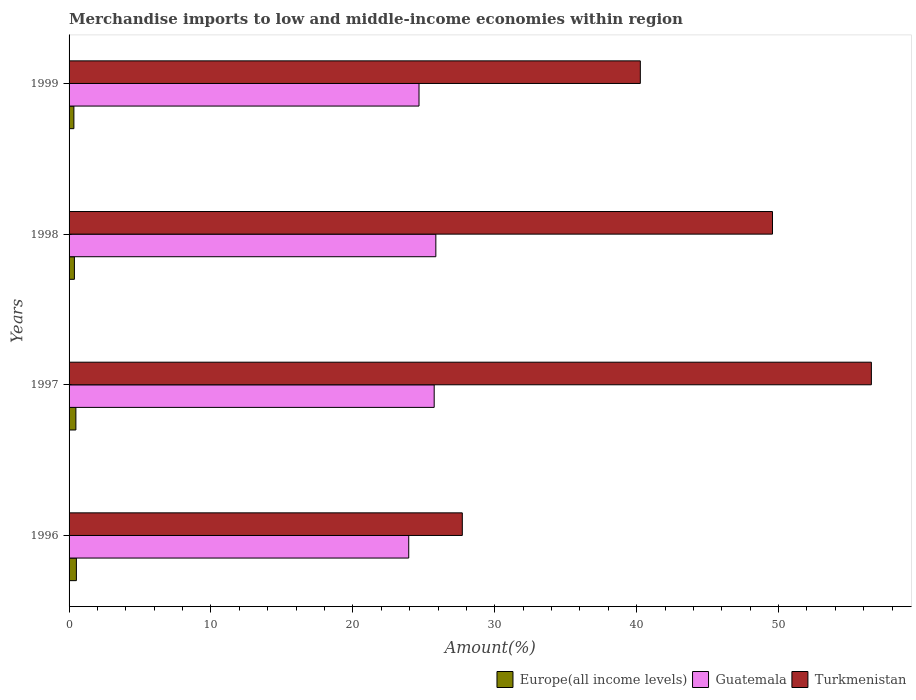Are the number of bars per tick equal to the number of legend labels?
Your answer should be compact. Yes. In how many cases, is the number of bars for a given year not equal to the number of legend labels?
Offer a terse response. 0. What is the percentage of amount earned from merchandise imports in Guatemala in 1999?
Offer a terse response. 24.66. Across all years, what is the maximum percentage of amount earned from merchandise imports in Guatemala?
Your response must be concise. 25.85. Across all years, what is the minimum percentage of amount earned from merchandise imports in Guatemala?
Make the answer very short. 23.94. In which year was the percentage of amount earned from merchandise imports in Turkmenistan minimum?
Provide a succinct answer. 1996. What is the total percentage of amount earned from merchandise imports in Guatemala in the graph?
Give a very brief answer. 100.17. What is the difference between the percentage of amount earned from merchandise imports in Europe(all income levels) in 1996 and that in 1999?
Give a very brief answer. 0.18. What is the difference between the percentage of amount earned from merchandise imports in Guatemala in 1998 and the percentage of amount earned from merchandise imports in Europe(all income levels) in 1999?
Your answer should be compact. 25.51. What is the average percentage of amount earned from merchandise imports in Europe(all income levels) per year?
Offer a terse response. 0.43. In the year 1996, what is the difference between the percentage of amount earned from merchandise imports in Europe(all income levels) and percentage of amount earned from merchandise imports in Turkmenistan?
Offer a very short reply. -27.2. In how many years, is the percentage of amount earned from merchandise imports in Turkmenistan greater than 36 %?
Provide a short and direct response. 3. What is the ratio of the percentage of amount earned from merchandise imports in Turkmenistan in 1996 to that in 1997?
Provide a succinct answer. 0.49. Is the difference between the percentage of amount earned from merchandise imports in Europe(all income levels) in 1996 and 1999 greater than the difference between the percentage of amount earned from merchandise imports in Turkmenistan in 1996 and 1999?
Offer a very short reply. Yes. What is the difference between the highest and the second highest percentage of amount earned from merchandise imports in Europe(all income levels)?
Ensure brevity in your answer.  0.04. What is the difference between the highest and the lowest percentage of amount earned from merchandise imports in Turkmenistan?
Provide a short and direct response. 28.83. What does the 2nd bar from the top in 1998 represents?
Provide a succinct answer. Guatemala. What does the 3rd bar from the bottom in 1998 represents?
Offer a very short reply. Turkmenistan. How many bars are there?
Your answer should be very brief. 12. What is the difference between two consecutive major ticks on the X-axis?
Keep it short and to the point. 10. What is the title of the graph?
Your response must be concise. Merchandise imports to low and middle-income economies within region. Does "Central African Republic" appear as one of the legend labels in the graph?
Keep it short and to the point. No. What is the label or title of the X-axis?
Offer a very short reply. Amount(%). What is the label or title of the Y-axis?
Provide a short and direct response. Years. What is the Amount(%) in Europe(all income levels) in 1996?
Offer a very short reply. 0.52. What is the Amount(%) of Guatemala in 1996?
Provide a succinct answer. 23.94. What is the Amount(%) of Turkmenistan in 1996?
Keep it short and to the point. 27.71. What is the Amount(%) in Europe(all income levels) in 1997?
Offer a very short reply. 0.48. What is the Amount(%) of Guatemala in 1997?
Provide a short and direct response. 25.73. What is the Amount(%) of Turkmenistan in 1997?
Your answer should be compact. 56.54. What is the Amount(%) of Europe(all income levels) in 1998?
Keep it short and to the point. 0.38. What is the Amount(%) in Guatemala in 1998?
Provide a short and direct response. 25.85. What is the Amount(%) of Turkmenistan in 1998?
Provide a short and direct response. 49.57. What is the Amount(%) of Europe(all income levels) in 1999?
Offer a terse response. 0.34. What is the Amount(%) of Guatemala in 1999?
Keep it short and to the point. 24.66. What is the Amount(%) of Turkmenistan in 1999?
Make the answer very short. 40.26. Across all years, what is the maximum Amount(%) of Europe(all income levels)?
Ensure brevity in your answer.  0.52. Across all years, what is the maximum Amount(%) in Guatemala?
Give a very brief answer. 25.85. Across all years, what is the maximum Amount(%) in Turkmenistan?
Provide a short and direct response. 56.54. Across all years, what is the minimum Amount(%) in Europe(all income levels)?
Provide a succinct answer. 0.34. Across all years, what is the minimum Amount(%) in Guatemala?
Ensure brevity in your answer.  23.94. Across all years, what is the minimum Amount(%) in Turkmenistan?
Give a very brief answer. 27.71. What is the total Amount(%) in Europe(all income levels) in the graph?
Your answer should be very brief. 1.71. What is the total Amount(%) of Guatemala in the graph?
Make the answer very short. 100.17. What is the total Amount(%) in Turkmenistan in the graph?
Ensure brevity in your answer.  174.07. What is the difference between the Amount(%) in Europe(all income levels) in 1996 and that in 1997?
Offer a very short reply. 0.04. What is the difference between the Amount(%) of Guatemala in 1996 and that in 1997?
Your response must be concise. -1.79. What is the difference between the Amount(%) in Turkmenistan in 1996 and that in 1997?
Make the answer very short. -28.83. What is the difference between the Amount(%) of Europe(all income levels) in 1996 and that in 1998?
Your answer should be very brief. 0.14. What is the difference between the Amount(%) in Guatemala in 1996 and that in 1998?
Offer a very short reply. -1.91. What is the difference between the Amount(%) in Turkmenistan in 1996 and that in 1998?
Give a very brief answer. -21.86. What is the difference between the Amount(%) in Europe(all income levels) in 1996 and that in 1999?
Ensure brevity in your answer.  0.18. What is the difference between the Amount(%) of Guatemala in 1996 and that in 1999?
Your response must be concise. -0.73. What is the difference between the Amount(%) of Turkmenistan in 1996 and that in 1999?
Ensure brevity in your answer.  -12.54. What is the difference between the Amount(%) of Europe(all income levels) in 1997 and that in 1998?
Make the answer very short. 0.1. What is the difference between the Amount(%) of Guatemala in 1997 and that in 1998?
Offer a terse response. -0.12. What is the difference between the Amount(%) in Turkmenistan in 1997 and that in 1998?
Keep it short and to the point. 6.97. What is the difference between the Amount(%) in Europe(all income levels) in 1997 and that in 1999?
Offer a very short reply. 0.14. What is the difference between the Amount(%) in Guatemala in 1997 and that in 1999?
Provide a short and direct response. 1.07. What is the difference between the Amount(%) in Turkmenistan in 1997 and that in 1999?
Provide a short and direct response. 16.28. What is the difference between the Amount(%) in Europe(all income levels) in 1998 and that in 1999?
Offer a very short reply. 0.04. What is the difference between the Amount(%) in Guatemala in 1998 and that in 1999?
Your answer should be very brief. 1.19. What is the difference between the Amount(%) in Turkmenistan in 1998 and that in 1999?
Your answer should be very brief. 9.31. What is the difference between the Amount(%) of Europe(all income levels) in 1996 and the Amount(%) of Guatemala in 1997?
Provide a short and direct response. -25.21. What is the difference between the Amount(%) in Europe(all income levels) in 1996 and the Amount(%) in Turkmenistan in 1997?
Your response must be concise. -56.02. What is the difference between the Amount(%) of Guatemala in 1996 and the Amount(%) of Turkmenistan in 1997?
Keep it short and to the point. -32.6. What is the difference between the Amount(%) in Europe(all income levels) in 1996 and the Amount(%) in Guatemala in 1998?
Provide a short and direct response. -25.33. What is the difference between the Amount(%) of Europe(all income levels) in 1996 and the Amount(%) of Turkmenistan in 1998?
Provide a short and direct response. -49.05. What is the difference between the Amount(%) of Guatemala in 1996 and the Amount(%) of Turkmenistan in 1998?
Provide a succinct answer. -25.63. What is the difference between the Amount(%) in Europe(all income levels) in 1996 and the Amount(%) in Guatemala in 1999?
Make the answer very short. -24.14. What is the difference between the Amount(%) in Europe(all income levels) in 1996 and the Amount(%) in Turkmenistan in 1999?
Offer a very short reply. -39.74. What is the difference between the Amount(%) in Guatemala in 1996 and the Amount(%) in Turkmenistan in 1999?
Offer a terse response. -16.32. What is the difference between the Amount(%) of Europe(all income levels) in 1997 and the Amount(%) of Guatemala in 1998?
Keep it short and to the point. -25.37. What is the difference between the Amount(%) in Europe(all income levels) in 1997 and the Amount(%) in Turkmenistan in 1998?
Keep it short and to the point. -49.09. What is the difference between the Amount(%) in Guatemala in 1997 and the Amount(%) in Turkmenistan in 1998?
Give a very brief answer. -23.84. What is the difference between the Amount(%) in Europe(all income levels) in 1997 and the Amount(%) in Guatemala in 1999?
Make the answer very short. -24.18. What is the difference between the Amount(%) in Europe(all income levels) in 1997 and the Amount(%) in Turkmenistan in 1999?
Provide a succinct answer. -39.78. What is the difference between the Amount(%) of Guatemala in 1997 and the Amount(%) of Turkmenistan in 1999?
Offer a terse response. -14.53. What is the difference between the Amount(%) in Europe(all income levels) in 1998 and the Amount(%) in Guatemala in 1999?
Offer a very short reply. -24.29. What is the difference between the Amount(%) of Europe(all income levels) in 1998 and the Amount(%) of Turkmenistan in 1999?
Provide a short and direct response. -39.88. What is the difference between the Amount(%) in Guatemala in 1998 and the Amount(%) in Turkmenistan in 1999?
Keep it short and to the point. -14.41. What is the average Amount(%) in Europe(all income levels) per year?
Provide a succinct answer. 0.43. What is the average Amount(%) in Guatemala per year?
Your answer should be very brief. 25.04. What is the average Amount(%) in Turkmenistan per year?
Offer a very short reply. 43.52. In the year 1996, what is the difference between the Amount(%) in Europe(all income levels) and Amount(%) in Guatemala?
Ensure brevity in your answer.  -23.42. In the year 1996, what is the difference between the Amount(%) in Europe(all income levels) and Amount(%) in Turkmenistan?
Provide a succinct answer. -27.2. In the year 1996, what is the difference between the Amount(%) in Guatemala and Amount(%) in Turkmenistan?
Keep it short and to the point. -3.78. In the year 1997, what is the difference between the Amount(%) in Europe(all income levels) and Amount(%) in Guatemala?
Offer a very short reply. -25.25. In the year 1997, what is the difference between the Amount(%) in Europe(all income levels) and Amount(%) in Turkmenistan?
Ensure brevity in your answer.  -56.06. In the year 1997, what is the difference between the Amount(%) of Guatemala and Amount(%) of Turkmenistan?
Your answer should be very brief. -30.81. In the year 1998, what is the difference between the Amount(%) in Europe(all income levels) and Amount(%) in Guatemala?
Provide a short and direct response. -25.47. In the year 1998, what is the difference between the Amount(%) of Europe(all income levels) and Amount(%) of Turkmenistan?
Give a very brief answer. -49.19. In the year 1998, what is the difference between the Amount(%) of Guatemala and Amount(%) of Turkmenistan?
Offer a terse response. -23.72. In the year 1999, what is the difference between the Amount(%) in Europe(all income levels) and Amount(%) in Guatemala?
Ensure brevity in your answer.  -24.32. In the year 1999, what is the difference between the Amount(%) in Europe(all income levels) and Amount(%) in Turkmenistan?
Offer a very short reply. -39.92. In the year 1999, what is the difference between the Amount(%) of Guatemala and Amount(%) of Turkmenistan?
Give a very brief answer. -15.6. What is the ratio of the Amount(%) in Europe(all income levels) in 1996 to that in 1997?
Offer a very short reply. 1.07. What is the ratio of the Amount(%) in Guatemala in 1996 to that in 1997?
Offer a very short reply. 0.93. What is the ratio of the Amount(%) in Turkmenistan in 1996 to that in 1997?
Offer a terse response. 0.49. What is the ratio of the Amount(%) of Europe(all income levels) in 1996 to that in 1998?
Offer a very short reply. 1.37. What is the ratio of the Amount(%) in Guatemala in 1996 to that in 1998?
Your response must be concise. 0.93. What is the ratio of the Amount(%) of Turkmenistan in 1996 to that in 1998?
Give a very brief answer. 0.56. What is the ratio of the Amount(%) in Europe(all income levels) in 1996 to that in 1999?
Provide a short and direct response. 1.52. What is the ratio of the Amount(%) in Guatemala in 1996 to that in 1999?
Offer a very short reply. 0.97. What is the ratio of the Amount(%) of Turkmenistan in 1996 to that in 1999?
Offer a very short reply. 0.69. What is the ratio of the Amount(%) of Europe(all income levels) in 1997 to that in 1998?
Give a very brief answer. 1.28. What is the ratio of the Amount(%) of Guatemala in 1997 to that in 1998?
Your response must be concise. 1. What is the ratio of the Amount(%) of Turkmenistan in 1997 to that in 1998?
Ensure brevity in your answer.  1.14. What is the ratio of the Amount(%) in Europe(all income levels) in 1997 to that in 1999?
Ensure brevity in your answer.  1.41. What is the ratio of the Amount(%) in Guatemala in 1997 to that in 1999?
Give a very brief answer. 1.04. What is the ratio of the Amount(%) in Turkmenistan in 1997 to that in 1999?
Give a very brief answer. 1.4. What is the ratio of the Amount(%) of Europe(all income levels) in 1998 to that in 1999?
Provide a short and direct response. 1.11. What is the ratio of the Amount(%) in Guatemala in 1998 to that in 1999?
Offer a very short reply. 1.05. What is the ratio of the Amount(%) of Turkmenistan in 1998 to that in 1999?
Provide a short and direct response. 1.23. What is the difference between the highest and the second highest Amount(%) of Europe(all income levels)?
Make the answer very short. 0.04. What is the difference between the highest and the second highest Amount(%) in Guatemala?
Keep it short and to the point. 0.12. What is the difference between the highest and the second highest Amount(%) in Turkmenistan?
Give a very brief answer. 6.97. What is the difference between the highest and the lowest Amount(%) of Europe(all income levels)?
Offer a terse response. 0.18. What is the difference between the highest and the lowest Amount(%) of Guatemala?
Provide a succinct answer. 1.91. What is the difference between the highest and the lowest Amount(%) in Turkmenistan?
Provide a succinct answer. 28.83. 